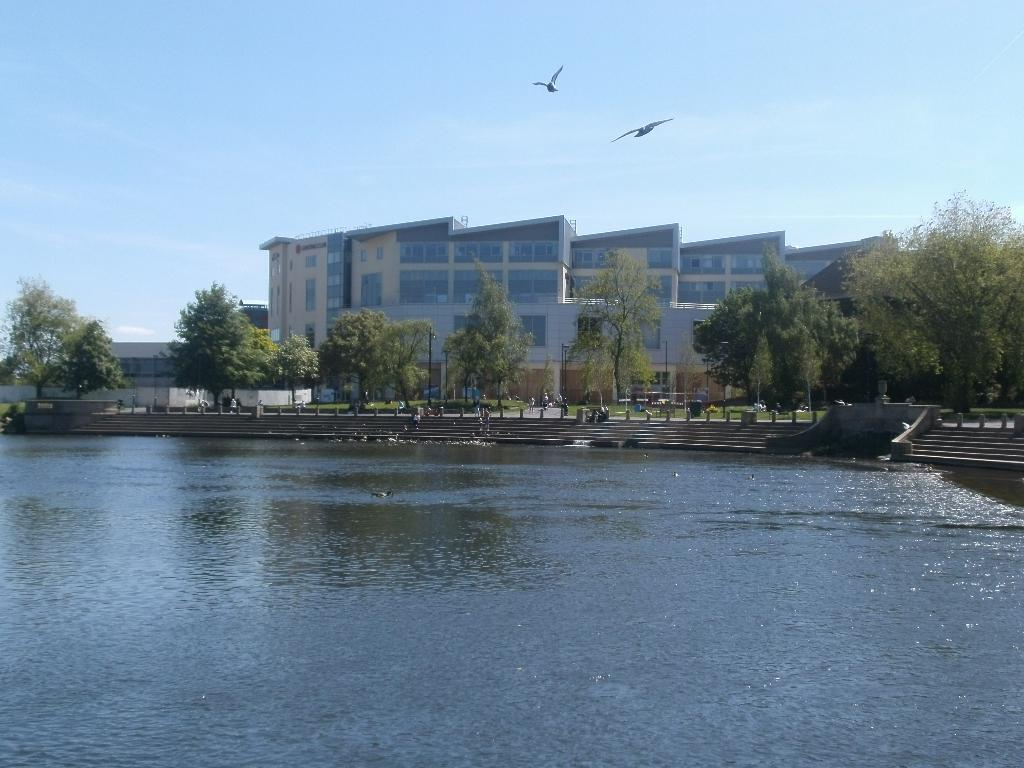What is the primary element visible in the image? There is water in the image. What architectural feature is located near the water? There are stairs near the water. What objects can be seen in the image besides the water and stairs? There are poles, people, trees, and a building visible in the image. What is visible in the background of the image? The sky is visible in the background of the image. What type of toothbrush is being used by the people in the image? There is no toothbrush present in the image; people are not using toothbrushes. What is the opinion of the trees about the water in the image? Trees do not have opinions, as they are inanimate objects. 